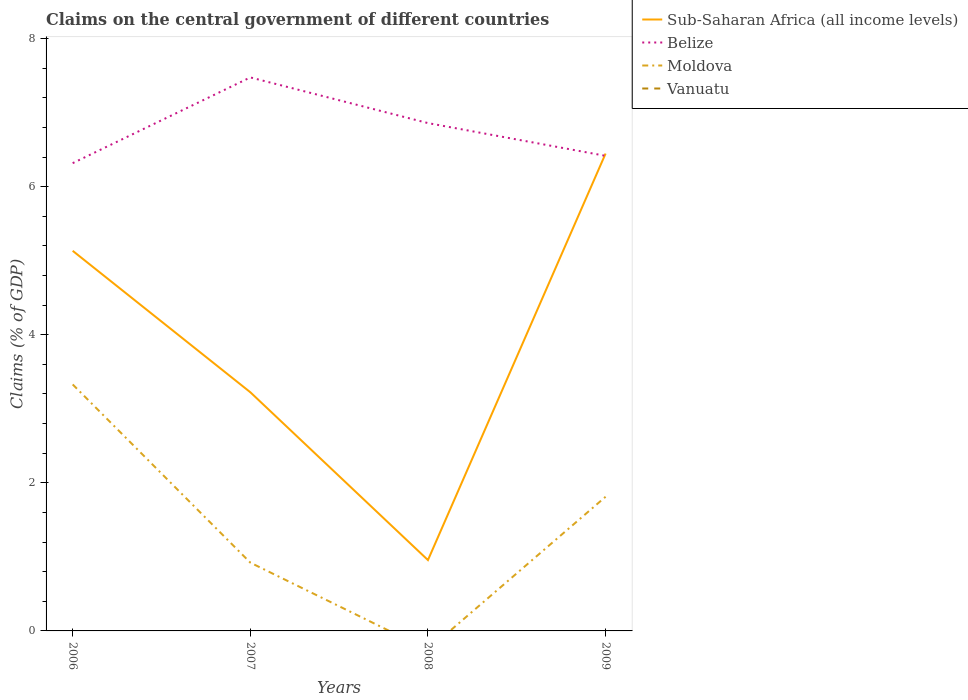Does the line corresponding to Vanuatu intersect with the line corresponding to Belize?
Give a very brief answer. No. Is the number of lines equal to the number of legend labels?
Offer a terse response. No. Across all years, what is the maximum percentage of GDP claimed on the central government in Moldova?
Keep it short and to the point. 0. What is the total percentage of GDP claimed on the central government in Belize in the graph?
Your response must be concise. 0.62. What is the difference between the highest and the second highest percentage of GDP claimed on the central government in Moldova?
Provide a short and direct response. 3.33. Is the percentage of GDP claimed on the central government in Moldova strictly greater than the percentage of GDP claimed on the central government in Belize over the years?
Ensure brevity in your answer.  Yes. What is the difference between two consecutive major ticks on the Y-axis?
Keep it short and to the point. 2. Are the values on the major ticks of Y-axis written in scientific E-notation?
Keep it short and to the point. No. Where does the legend appear in the graph?
Offer a very short reply. Top right. How are the legend labels stacked?
Keep it short and to the point. Vertical. What is the title of the graph?
Your response must be concise. Claims on the central government of different countries. What is the label or title of the X-axis?
Your response must be concise. Years. What is the label or title of the Y-axis?
Your response must be concise. Claims (% of GDP). What is the Claims (% of GDP) in Sub-Saharan Africa (all income levels) in 2006?
Make the answer very short. 5.13. What is the Claims (% of GDP) in Belize in 2006?
Provide a succinct answer. 6.32. What is the Claims (% of GDP) of Moldova in 2006?
Make the answer very short. 3.33. What is the Claims (% of GDP) in Sub-Saharan Africa (all income levels) in 2007?
Your answer should be compact. 3.22. What is the Claims (% of GDP) of Belize in 2007?
Make the answer very short. 7.47. What is the Claims (% of GDP) of Moldova in 2007?
Provide a succinct answer. 0.92. What is the Claims (% of GDP) in Vanuatu in 2007?
Your answer should be very brief. 0. What is the Claims (% of GDP) in Sub-Saharan Africa (all income levels) in 2008?
Provide a succinct answer. 0.96. What is the Claims (% of GDP) of Belize in 2008?
Make the answer very short. 6.86. What is the Claims (% of GDP) in Vanuatu in 2008?
Offer a terse response. 0. What is the Claims (% of GDP) in Sub-Saharan Africa (all income levels) in 2009?
Keep it short and to the point. 6.45. What is the Claims (% of GDP) of Belize in 2009?
Provide a short and direct response. 6.42. What is the Claims (% of GDP) of Moldova in 2009?
Offer a very short reply. 1.81. What is the Claims (% of GDP) in Vanuatu in 2009?
Give a very brief answer. 0. Across all years, what is the maximum Claims (% of GDP) of Sub-Saharan Africa (all income levels)?
Your answer should be compact. 6.45. Across all years, what is the maximum Claims (% of GDP) of Belize?
Ensure brevity in your answer.  7.47. Across all years, what is the maximum Claims (% of GDP) of Moldova?
Provide a succinct answer. 3.33. Across all years, what is the minimum Claims (% of GDP) of Sub-Saharan Africa (all income levels)?
Keep it short and to the point. 0.96. Across all years, what is the minimum Claims (% of GDP) of Belize?
Provide a succinct answer. 6.32. Across all years, what is the minimum Claims (% of GDP) of Moldova?
Your answer should be very brief. 0. What is the total Claims (% of GDP) of Sub-Saharan Africa (all income levels) in the graph?
Give a very brief answer. 15.76. What is the total Claims (% of GDP) of Belize in the graph?
Offer a very short reply. 27.07. What is the total Claims (% of GDP) in Moldova in the graph?
Your answer should be very brief. 6.06. What is the total Claims (% of GDP) in Vanuatu in the graph?
Provide a short and direct response. 0. What is the difference between the Claims (% of GDP) of Sub-Saharan Africa (all income levels) in 2006 and that in 2007?
Keep it short and to the point. 1.91. What is the difference between the Claims (% of GDP) of Belize in 2006 and that in 2007?
Your response must be concise. -1.16. What is the difference between the Claims (% of GDP) in Moldova in 2006 and that in 2007?
Offer a very short reply. 2.41. What is the difference between the Claims (% of GDP) of Sub-Saharan Africa (all income levels) in 2006 and that in 2008?
Provide a succinct answer. 4.18. What is the difference between the Claims (% of GDP) of Belize in 2006 and that in 2008?
Provide a short and direct response. -0.54. What is the difference between the Claims (% of GDP) in Sub-Saharan Africa (all income levels) in 2006 and that in 2009?
Give a very brief answer. -1.31. What is the difference between the Claims (% of GDP) in Belize in 2006 and that in 2009?
Provide a succinct answer. -0.1. What is the difference between the Claims (% of GDP) in Moldova in 2006 and that in 2009?
Your answer should be very brief. 1.52. What is the difference between the Claims (% of GDP) of Sub-Saharan Africa (all income levels) in 2007 and that in 2008?
Your answer should be compact. 2.27. What is the difference between the Claims (% of GDP) in Belize in 2007 and that in 2008?
Make the answer very short. 0.62. What is the difference between the Claims (% of GDP) of Sub-Saharan Africa (all income levels) in 2007 and that in 2009?
Make the answer very short. -3.22. What is the difference between the Claims (% of GDP) in Belize in 2007 and that in 2009?
Ensure brevity in your answer.  1.06. What is the difference between the Claims (% of GDP) of Moldova in 2007 and that in 2009?
Provide a succinct answer. -0.89. What is the difference between the Claims (% of GDP) in Sub-Saharan Africa (all income levels) in 2008 and that in 2009?
Ensure brevity in your answer.  -5.49. What is the difference between the Claims (% of GDP) in Belize in 2008 and that in 2009?
Offer a terse response. 0.44. What is the difference between the Claims (% of GDP) of Sub-Saharan Africa (all income levels) in 2006 and the Claims (% of GDP) of Belize in 2007?
Keep it short and to the point. -2.34. What is the difference between the Claims (% of GDP) in Sub-Saharan Africa (all income levels) in 2006 and the Claims (% of GDP) in Moldova in 2007?
Provide a short and direct response. 4.21. What is the difference between the Claims (% of GDP) of Belize in 2006 and the Claims (% of GDP) of Moldova in 2007?
Make the answer very short. 5.39. What is the difference between the Claims (% of GDP) of Sub-Saharan Africa (all income levels) in 2006 and the Claims (% of GDP) of Belize in 2008?
Offer a terse response. -1.72. What is the difference between the Claims (% of GDP) of Sub-Saharan Africa (all income levels) in 2006 and the Claims (% of GDP) of Belize in 2009?
Your response must be concise. -1.28. What is the difference between the Claims (% of GDP) in Sub-Saharan Africa (all income levels) in 2006 and the Claims (% of GDP) in Moldova in 2009?
Your answer should be compact. 3.32. What is the difference between the Claims (% of GDP) of Belize in 2006 and the Claims (% of GDP) of Moldova in 2009?
Your answer should be compact. 4.51. What is the difference between the Claims (% of GDP) of Sub-Saharan Africa (all income levels) in 2007 and the Claims (% of GDP) of Belize in 2008?
Make the answer very short. -3.63. What is the difference between the Claims (% of GDP) in Sub-Saharan Africa (all income levels) in 2007 and the Claims (% of GDP) in Belize in 2009?
Your answer should be compact. -3.19. What is the difference between the Claims (% of GDP) in Sub-Saharan Africa (all income levels) in 2007 and the Claims (% of GDP) in Moldova in 2009?
Provide a short and direct response. 1.41. What is the difference between the Claims (% of GDP) in Belize in 2007 and the Claims (% of GDP) in Moldova in 2009?
Give a very brief answer. 5.66. What is the difference between the Claims (% of GDP) of Sub-Saharan Africa (all income levels) in 2008 and the Claims (% of GDP) of Belize in 2009?
Provide a short and direct response. -5.46. What is the difference between the Claims (% of GDP) of Sub-Saharan Africa (all income levels) in 2008 and the Claims (% of GDP) of Moldova in 2009?
Your answer should be very brief. -0.85. What is the difference between the Claims (% of GDP) in Belize in 2008 and the Claims (% of GDP) in Moldova in 2009?
Your response must be concise. 5.05. What is the average Claims (% of GDP) in Sub-Saharan Africa (all income levels) per year?
Ensure brevity in your answer.  3.94. What is the average Claims (% of GDP) of Belize per year?
Provide a short and direct response. 6.77. What is the average Claims (% of GDP) in Moldova per year?
Make the answer very short. 1.52. What is the average Claims (% of GDP) in Vanuatu per year?
Ensure brevity in your answer.  0. In the year 2006, what is the difference between the Claims (% of GDP) in Sub-Saharan Africa (all income levels) and Claims (% of GDP) in Belize?
Your answer should be compact. -1.18. In the year 2006, what is the difference between the Claims (% of GDP) of Sub-Saharan Africa (all income levels) and Claims (% of GDP) of Moldova?
Give a very brief answer. 1.8. In the year 2006, what is the difference between the Claims (% of GDP) of Belize and Claims (% of GDP) of Moldova?
Make the answer very short. 2.99. In the year 2007, what is the difference between the Claims (% of GDP) of Sub-Saharan Africa (all income levels) and Claims (% of GDP) of Belize?
Offer a terse response. -4.25. In the year 2007, what is the difference between the Claims (% of GDP) of Sub-Saharan Africa (all income levels) and Claims (% of GDP) of Moldova?
Your response must be concise. 2.3. In the year 2007, what is the difference between the Claims (% of GDP) of Belize and Claims (% of GDP) of Moldova?
Your answer should be compact. 6.55. In the year 2008, what is the difference between the Claims (% of GDP) in Sub-Saharan Africa (all income levels) and Claims (% of GDP) in Belize?
Give a very brief answer. -5.9. In the year 2009, what is the difference between the Claims (% of GDP) of Sub-Saharan Africa (all income levels) and Claims (% of GDP) of Belize?
Make the answer very short. 0.03. In the year 2009, what is the difference between the Claims (% of GDP) in Sub-Saharan Africa (all income levels) and Claims (% of GDP) in Moldova?
Provide a short and direct response. 4.63. In the year 2009, what is the difference between the Claims (% of GDP) of Belize and Claims (% of GDP) of Moldova?
Keep it short and to the point. 4.6. What is the ratio of the Claims (% of GDP) of Sub-Saharan Africa (all income levels) in 2006 to that in 2007?
Your answer should be compact. 1.59. What is the ratio of the Claims (% of GDP) of Belize in 2006 to that in 2007?
Provide a succinct answer. 0.85. What is the ratio of the Claims (% of GDP) of Moldova in 2006 to that in 2007?
Provide a short and direct response. 3.61. What is the ratio of the Claims (% of GDP) of Sub-Saharan Africa (all income levels) in 2006 to that in 2008?
Provide a short and direct response. 5.37. What is the ratio of the Claims (% of GDP) of Belize in 2006 to that in 2008?
Offer a very short reply. 0.92. What is the ratio of the Claims (% of GDP) in Sub-Saharan Africa (all income levels) in 2006 to that in 2009?
Offer a very short reply. 0.8. What is the ratio of the Claims (% of GDP) of Belize in 2006 to that in 2009?
Keep it short and to the point. 0.98. What is the ratio of the Claims (% of GDP) of Moldova in 2006 to that in 2009?
Your answer should be very brief. 1.84. What is the ratio of the Claims (% of GDP) in Sub-Saharan Africa (all income levels) in 2007 to that in 2008?
Your answer should be very brief. 3.37. What is the ratio of the Claims (% of GDP) in Belize in 2007 to that in 2008?
Keep it short and to the point. 1.09. What is the ratio of the Claims (% of GDP) in Sub-Saharan Africa (all income levels) in 2007 to that in 2009?
Give a very brief answer. 0.5. What is the ratio of the Claims (% of GDP) of Belize in 2007 to that in 2009?
Your answer should be very brief. 1.17. What is the ratio of the Claims (% of GDP) in Moldova in 2007 to that in 2009?
Your response must be concise. 0.51. What is the ratio of the Claims (% of GDP) in Sub-Saharan Africa (all income levels) in 2008 to that in 2009?
Make the answer very short. 0.15. What is the ratio of the Claims (% of GDP) in Belize in 2008 to that in 2009?
Offer a very short reply. 1.07. What is the difference between the highest and the second highest Claims (% of GDP) in Sub-Saharan Africa (all income levels)?
Make the answer very short. 1.31. What is the difference between the highest and the second highest Claims (% of GDP) of Belize?
Give a very brief answer. 0.62. What is the difference between the highest and the second highest Claims (% of GDP) of Moldova?
Provide a succinct answer. 1.52. What is the difference between the highest and the lowest Claims (% of GDP) in Sub-Saharan Africa (all income levels)?
Your answer should be compact. 5.49. What is the difference between the highest and the lowest Claims (% of GDP) of Belize?
Offer a terse response. 1.16. What is the difference between the highest and the lowest Claims (% of GDP) in Moldova?
Make the answer very short. 3.33. 